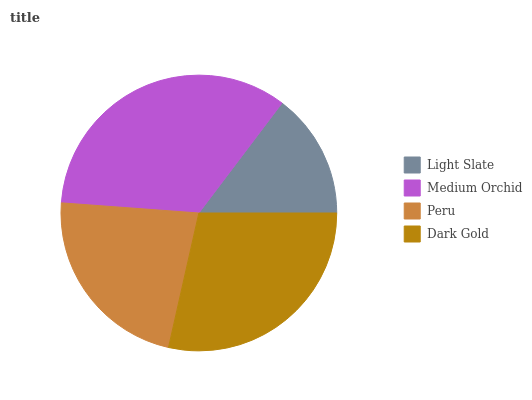Is Light Slate the minimum?
Answer yes or no. Yes. Is Medium Orchid the maximum?
Answer yes or no. Yes. Is Peru the minimum?
Answer yes or no. No. Is Peru the maximum?
Answer yes or no. No. Is Medium Orchid greater than Peru?
Answer yes or no. Yes. Is Peru less than Medium Orchid?
Answer yes or no. Yes. Is Peru greater than Medium Orchid?
Answer yes or no. No. Is Medium Orchid less than Peru?
Answer yes or no. No. Is Dark Gold the high median?
Answer yes or no. Yes. Is Peru the low median?
Answer yes or no. Yes. Is Peru the high median?
Answer yes or no. No. Is Dark Gold the low median?
Answer yes or no. No. 